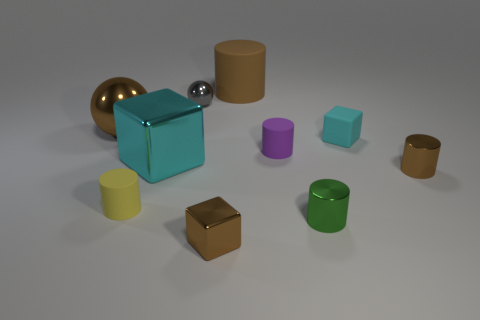What color is the large block?
Provide a short and direct response. Cyan. What material is the large thing that is the same shape as the tiny purple rubber thing?
Make the answer very short. Rubber. Do the large rubber cylinder and the big metal sphere have the same color?
Your response must be concise. Yes. There is a small brown object in front of the tiny yellow matte cylinder that is on the left side of the large cyan shiny thing; what shape is it?
Offer a terse response. Cube. The gray thing that is the same material as the brown sphere is what shape?
Offer a very short reply. Sphere. How many other objects are there of the same shape as the large cyan shiny thing?
Give a very brief answer. 2. There is a brown metal object that is to the left of the yellow cylinder; is its size the same as the brown shiny cylinder?
Provide a short and direct response. No. Is the number of purple rubber objects that are left of the purple cylinder greater than the number of shiny balls?
Provide a short and direct response. No. There is a rubber thing that is in front of the cyan metal object; how many brown matte objects are left of it?
Ensure brevity in your answer.  0. Are there fewer tiny gray balls on the right side of the brown shiny cylinder than large spheres?
Provide a short and direct response. Yes. 